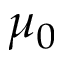<formula> <loc_0><loc_0><loc_500><loc_500>\mu _ { 0 }</formula> 